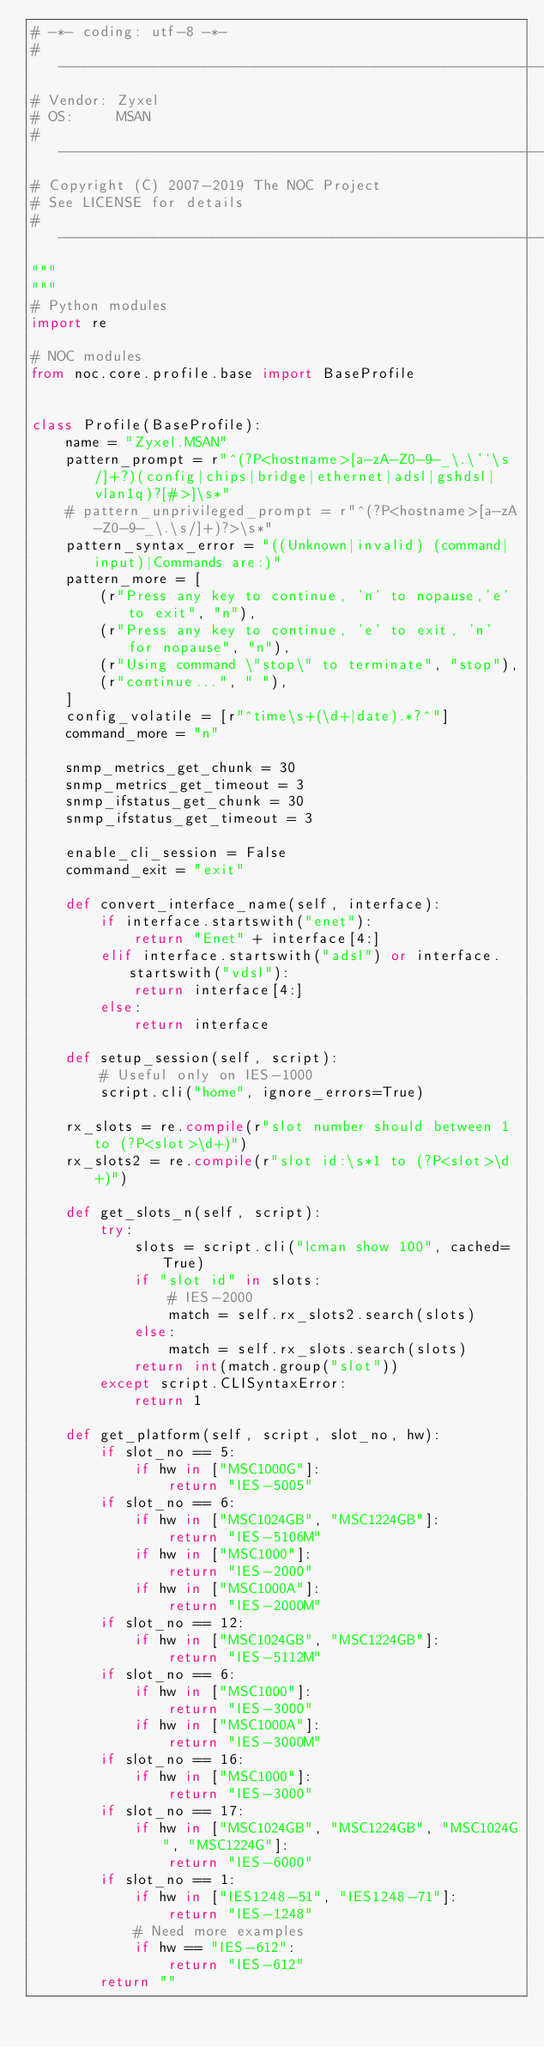<code> <loc_0><loc_0><loc_500><loc_500><_Python_># -*- coding: utf-8 -*-
# ---------------------------------------------------------------------
# Vendor: Zyxel
# OS:     MSAN
# ---------------------------------------------------------------------
# Copyright (C) 2007-2019 The NOC Project
# See LICENSE for details
# ---------------------------------------------------------------------
"""
"""
# Python modules
import re

# NOC modules
from noc.core.profile.base import BaseProfile


class Profile(BaseProfile):
    name = "Zyxel.MSAN"
    pattern_prompt = r"^(?P<hostname>[a-zA-Z0-9-_\.\'`\s/]+?)(config|chips|bridge|ethernet|adsl|gshdsl|vlan1q)?[#>]\s*"
    # pattern_unprivileged_prompt = r"^(?P<hostname>[a-zA-Z0-9-_\.\s/]+)?>\s*"
    pattern_syntax_error = "((Unknown|invalid) (command|input)|Commands are:)"
    pattern_more = [
        (r"Press any key to continue, 'n' to nopause,'e' to exit", "n"),
        (r"Press any key to continue, 'e' to exit, 'n' for nopause", "n"),
        (r"Using command \"stop\" to terminate", "stop"),
        (r"continue...", " "),
    ]
    config_volatile = [r"^time\s+(\d+|date).*?^"]
    command_more = "n"

    snmp_metrics_get_chunk = 30
    snmp_metrics_get_timeout = 3
    snmp_ifstatus_get_chunk = 30
    snmp_ifstatus_get_timeout = 3

    enable_cli_session = False
    command_exit = "exit"

    def convert_interface_name(self, interface):
        if interface.startswith("enet"):
            return "Enet" + interface[4:]
        elif interface.startswith("adsl") or interface.startswith("vdsl"):
            return interface[4:]
        else:
            return interface

    def setup_session(self, script):
        # Useful only on IES-1000
        script.cli("home", ignore_errors=True)

    rx_slots = re.compile(r"slot number should between 1 to (?P<slot>\d+)")
    rx_slots2 = re.compile(r"slot id:\s*1 to (?P<slot>\d+)")

    def get_slots_n(self, script):
        try:
            slots = script.cli("lcman show 100", cached=True)
            if "slot id" in slots:
                # IES-2000
                match = self.rx_slots2.search(slots)
            else:
                match = self.rx_slots.search(slots)
            return int(match.group("slot"))
        except script.CLISyntaxError:
            return 1

    def get_platform(self, script, slot_no, hw):
        if slot_no == 5:
            if hw in ["MSC1000G"]:
                return "IES-5005"
        if slot_no == 6:
            if hw in ["MSC1024GB", "MSC1224GB"]:
                return "IES-5106M"
            if hw in ["MSC1000"]:
                return "IES-2000"
            if hw in ["MSC1000A"]:
                return "IES-2000M"
        if slot_no == 12:
            if hw in ["MSC1024GB", "MSC1224GB"]:
                return "IES-5112M"
        if slot_no == 6:
            if hw in ["MSC1000"]:
                return "IES-3000"
            if hw in ["MSC1000A"]:
                return "IES-3000M"
        if slot_no == 16:
            if hw in ["MSC1000"]:
                return "IES-3000"
        if slot_no == 17:
            if hw in ["MSC1024GB", "MSC1224GB", "MSC1024G", "MSC1224G"]:
                return "IES-6000"
        if slot_no == 1:
            if hw in ["IES1248-51", "IES1248-71"]:
                return "IES-1248"
            # Need more examples
            if hw == "IES-612":
                return "IES-612"
        return ""
</code> 